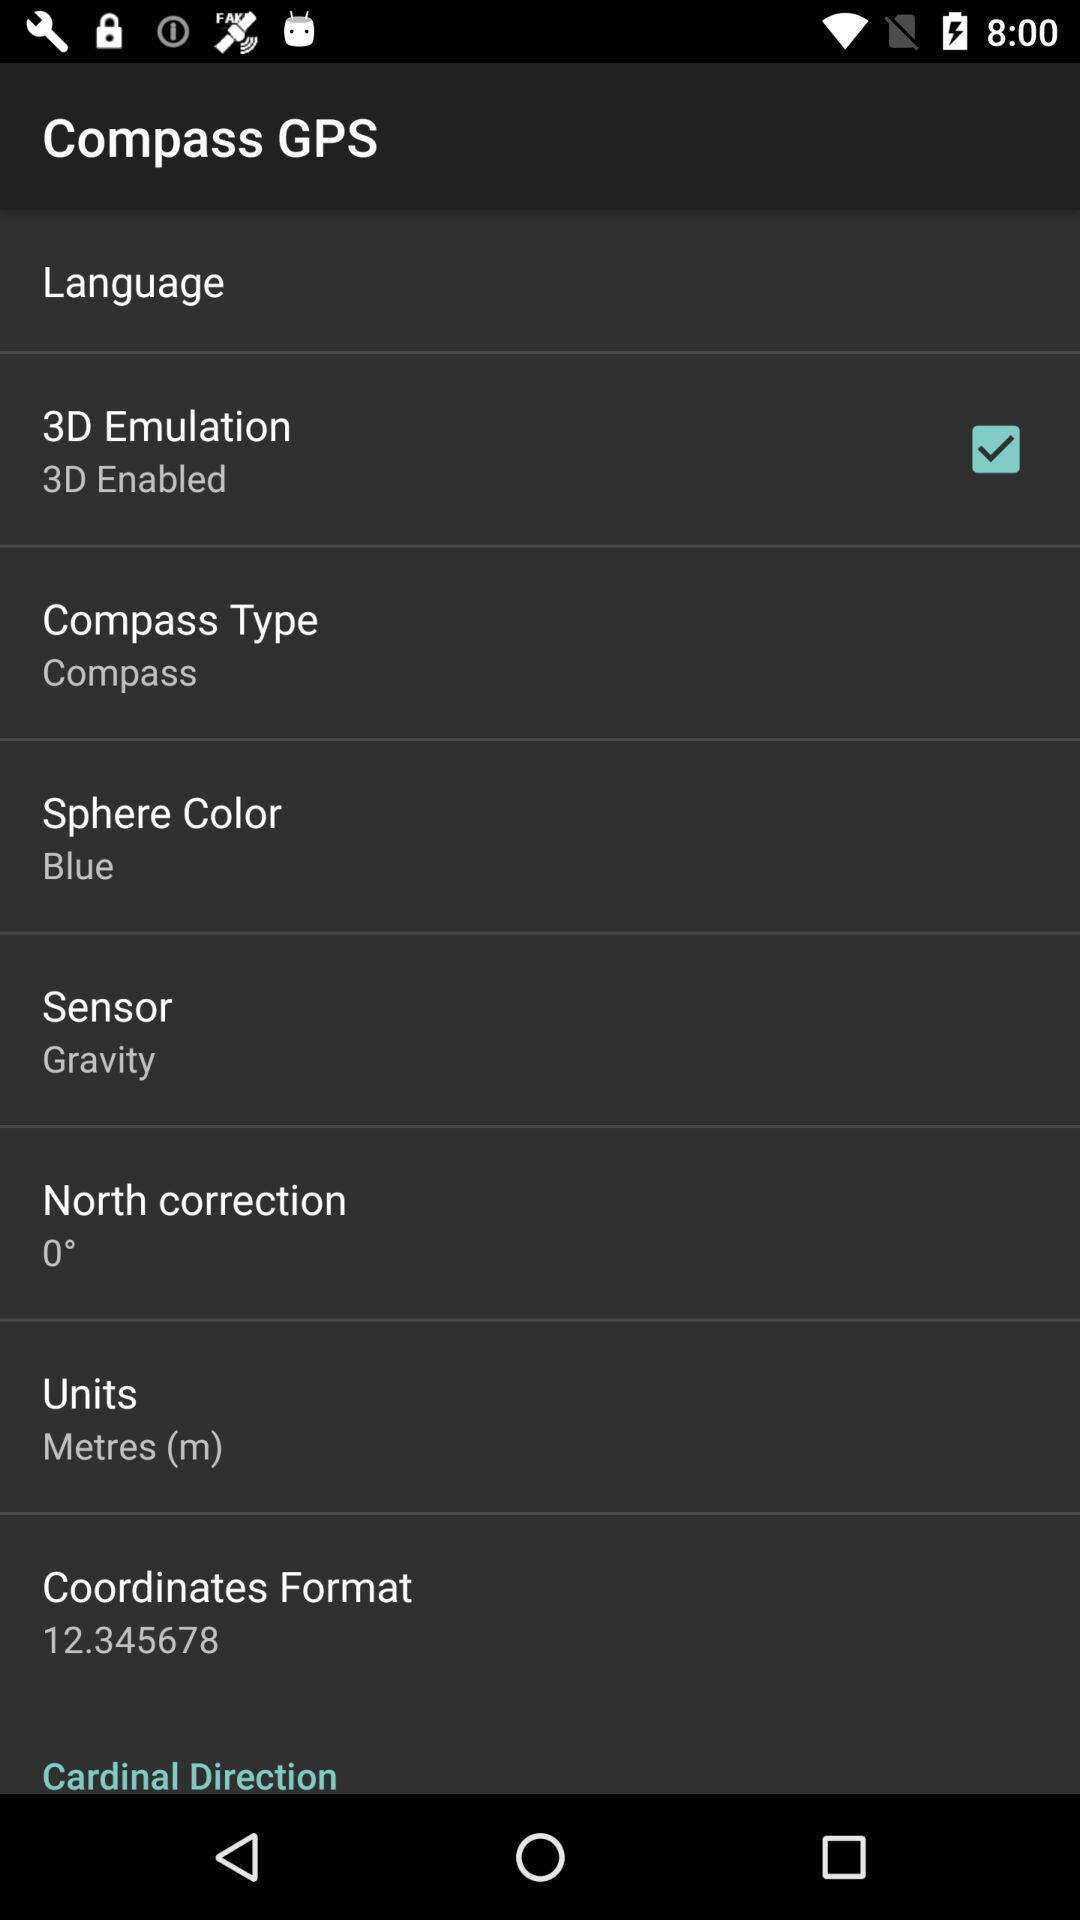What is the latitude of the user's current location?
Answer the question using a single word or phrase. 37.788099 